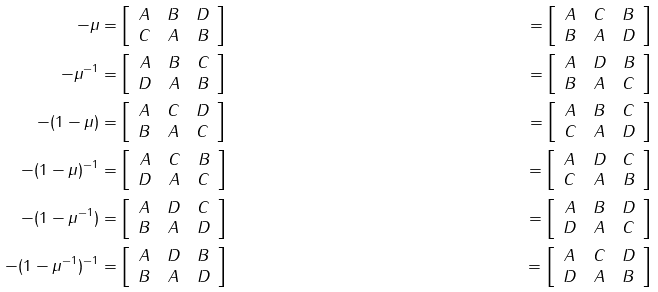Convert formula to latex. <formula><loc_0><loc_0><loc_500><loc_500>- \mu & = \left [ \begin{array} { c c c } A & B & D \\ C & A & B \end{array} \right ] & = \left [ \begin{array} { c c c } A & C & B \\ B & A & D \end{array} \right ] \\ - \mu ^ { - 1 } & = \left [ \begin{array} { c c c } A & B & C \\ D & A & B \end{array} \right ] & = \left [ \begin{array} { c c c } A & D & B \\ B & A & C \end{array} \right ] \\ - ( 1 - \mu ) & = \left [ \begin{array} { c c c } A & C & D \\ B & A & C \end{array} \right ] & = \left [ \begin{array} { c c c } A & B & C \\ C & A & D \end{array} \right ] \\ - ( 1 - \mu ) ^ { - 1 } & = \left [ \begin{array} { c c c } A & C & B \\ D & A & C \end{array} \right ] & = \left [ \begin{array} { c c c } A & D & C \\ C & A & B \end{array} \right ] \\ - ( 1 - \mu ^ { - 1 } ) & = \left [ \begin{array} { c c c } A & D & C \\ B & A & D \end{array} \right ] & = \left [ \begin{array} { c c c } A & B & D \\ D & A & C \end{array} \right ] \\ - ( 1 - \mu ^ { - 1 } ) ^ { - 1 } & = \left [ \begin{array} { c c c } A & D & B \\ B & A & D \end{array} \right ] & = \left [ \begin{array} { c c c } A & C & D \\ D & A & B \end{array} \right ]</formula> 